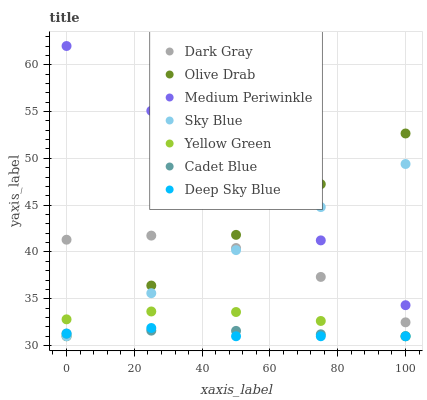Does Deep Sky Blue have the minimum area under the curve?
Answer yes or no. Yes. Does Medium Periwinkle have the maximum area under the curve?
Answer yes or no. Yes. Does Yellow Green have the minimum area under the curve?
Answer yes or no. No. Does Yellow Green have the maximum area under the curve?
Answer yes or no. No. Is Medium Periwinkle the smoothest?
Answer yes or no. Yes. Is Dark Gray the roughest?
Answer yes or no. Yes. Is Yellow Green the smoothest?
Answer yes or no. No. Is Yellow Green the roughest?
Answer yes or no. No. Does Cadet Blue have the lowest value?
Answer yes or no. Yes. Does Medium Periwinkle have the lowest value?
Answer yes or no. No. Does Medium Periwinkle have the highest value?
Answer yes or no. Yes. Does Yellow Green have the highest value?
Answer yes or no. No. Is Cadet Blue less than Dark Gray?
Answer yes or no. Yes. Is Medium Periwinkle greater than Yellow Green?
Answer yes or no. Yes. Does Deep Sky Blue intersect Cadet Blue?
Answer yes or no. Yes. Is Deep Sky Blue less than Cadet Blue?
Answer yes or no. No. Is Deep Sky Blue greater than Cadet Blue?
Answer yes or no. No. Does Cadet Blue intersect Dark Gray?
Answer yes or no. No. 